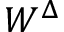Convert formula to latex. <formula><loc_0><loc_0><loc_500><loc_500>W ^ { \Delta }</formula> 